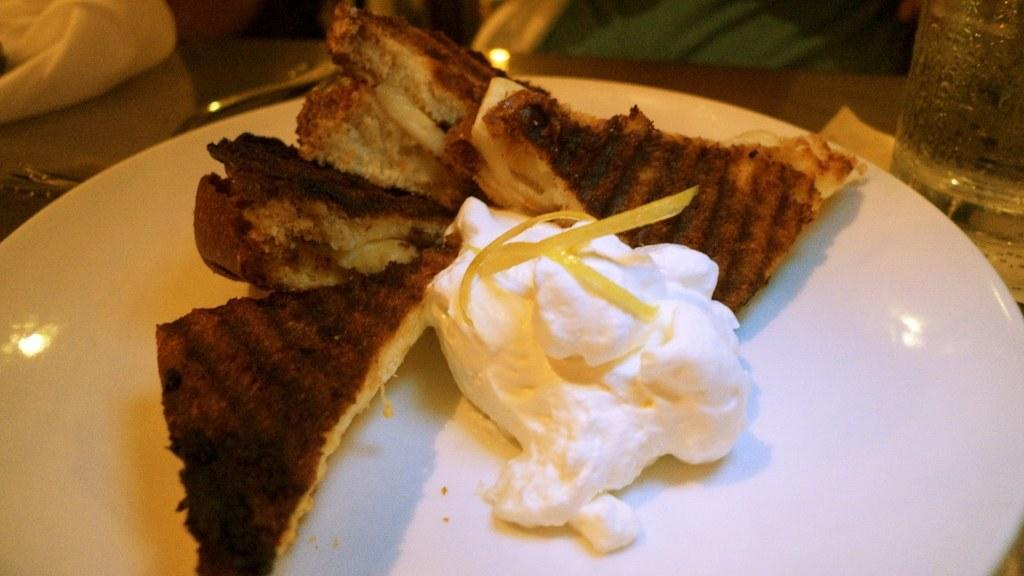What is on the plate that is visible in the image? There is food in a plate in the image. What else can be seen on the table in the image? There is a glass on the table in the image. Can you tell me how deep the lake is in the image? There is no lake present in the image; it only features a plate with food and a glass on the table. What type of punishment is being administered in the image? There is no punishment being administered in the image; it only features a plate with food and a glass on the table. 